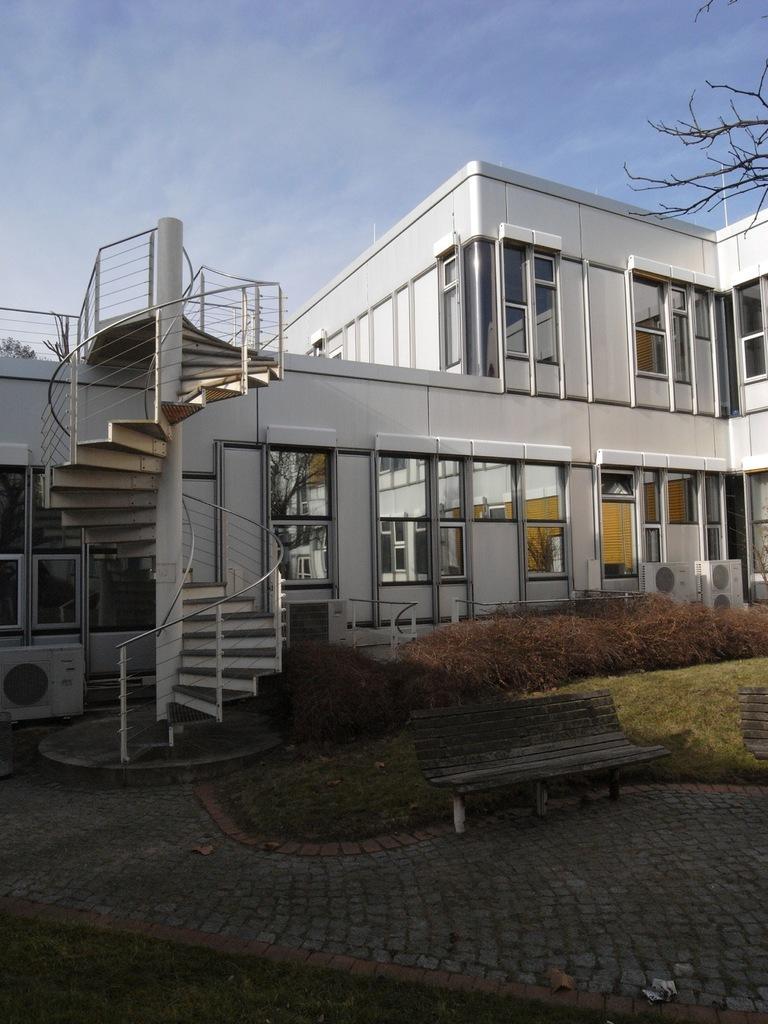Describe this image in one or two sentences. This image is taken outdoors. At the top of the image there is the sky with clouds. At the bottom of the image there is a ground with grass on it and there is a floor. In the middle of the image there is a building with walls, windows, a door, a roof, railings and stairs. There are three air conditioners. There are a few plants and there is an empty bench. At the top right of the image there is a tree. 